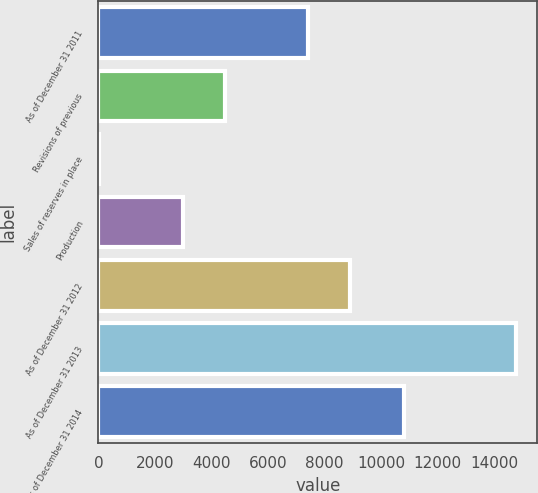Convert chart to OTSL. <chart><loc_0><loc_0><loc_500><loc_500><bar_chart><fcel>As of December 31 2011<fcel>Revisions of previous<fcel>Sales of reserves in place<fcel>Production<fcel>As of December 31 2012<fcel>As of December 31 2013<fcel>As of December 31 2014<nl><fcel>7409.5<fcel>4460.9<fcel>38<fcel>2986.6<fcel>8883.8<fcel>14781<fcel>10820<nl></chart> 